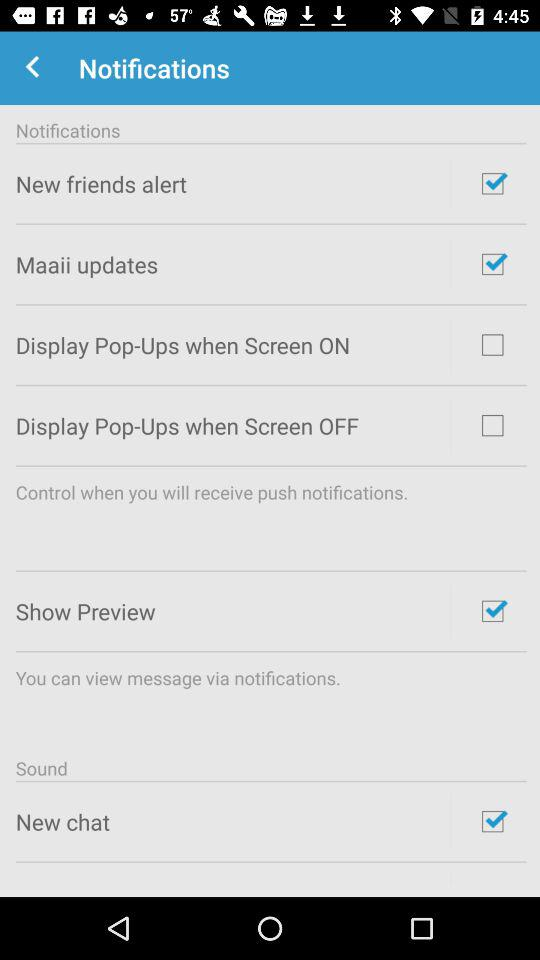What is the current status of the "Show Preview"? The current status is "on". 